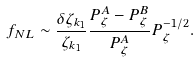Convert formula to latex. <formula><loc_0><loc_0><loc_500><loc_500>f _ { N L } \sim \frac { \delta \zeta _ { k _ { 1 } } } { \zeta _ { k _ { 1 } } } \frac { P _ { \zeta } ^ { A } - P _ { \zeta } ^ { B } } { P _ { \zeta } ^ { A } } P _ { \zeta } ^ { - 1 / 2 } .</formula> 